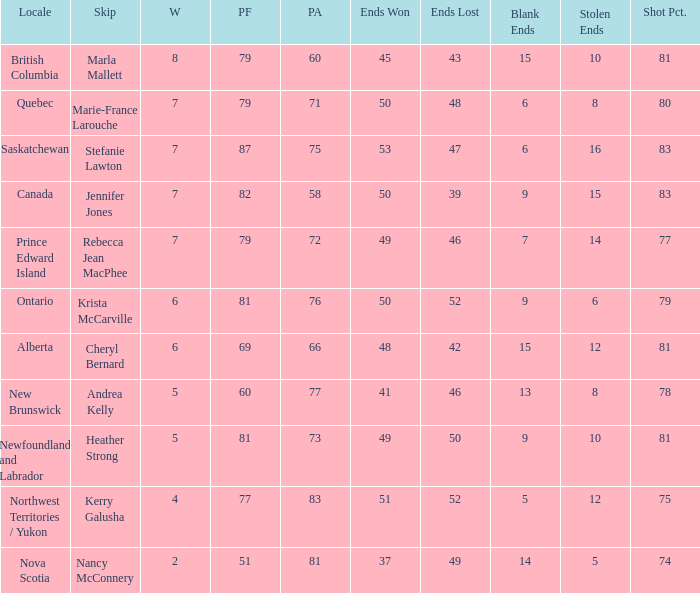Where was the shot pct 78? New Brunswick. 